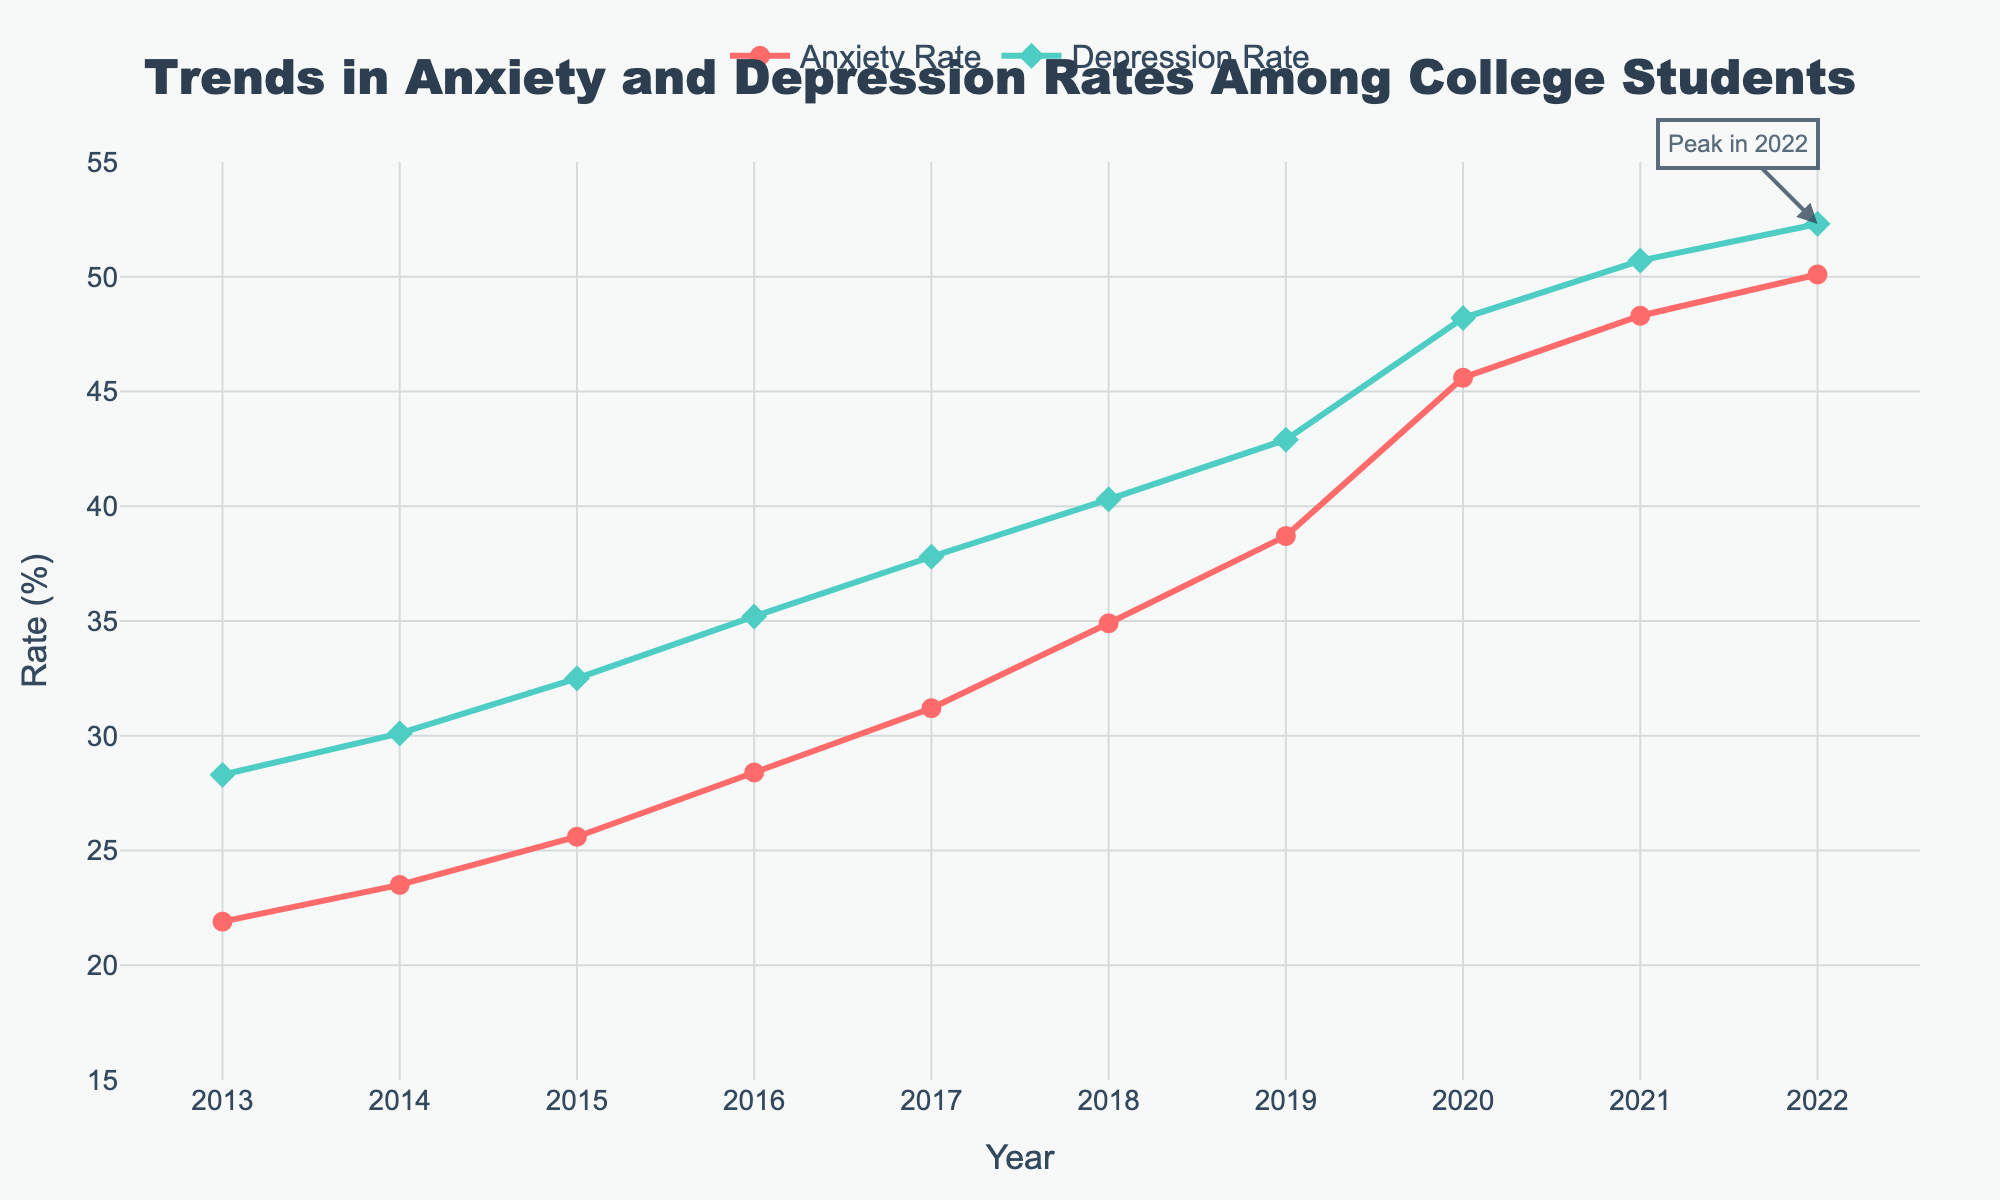What's the trend for anxiety rates from 2013 to 2022? To determine the trend, observe the line representing Anxiety Rate. It starts at 21.9% in 2013 and increases each year, reaching 50.1% in 2022. The trend shows a steady increase over the years.
Answer: Steady increase During which year did the depression rate have the highest increase compared to the previous year? Analyze the yearly increments for the Depression Rate. The largest yearly increase is between 2019 and 2020, where it rose from 42.9% to 48.2%, an increase of 5.3%.
Answer: 2020 What is the median anxiety rate over the past decade? The median is the middle value when data points are arranged in order. The anxiety rates are: 21.9, 23.5, 25.6, 28.4, 31.2, 34.9, 38.7, 45.6, 48.3, 50.1. The median value lies between the 5th and 6th values in this sorted list: (31.2 + 34.9) / 2 = 33.05%.
Answer: 33.05% By how much did the depression rate increase from 2013 to 2022? Subtract the Depression Rate in 2013 from the rate in 2022: 52.3% - 28.3% = 24.0%.
Answer: 24.0% Which year has the highest depression rate and what is it? Locate the peak of the Depression Rate line in the chart. The highest rate is in 2022, indicated by an annotation in the chart, at 52.3%.
Answer: 2022, 52.3% Compare the anxiety and depression rates in 2017. Which one was higher? Look at the rates for both in 2017: Anxiety Rate is 31.2% and Depression Rate is 37.8%. The Depression Rate is higher.
Answer: Depression Rate What is the difference between the anxiety rates in 2016 and 2020? Subtract the Anxiety Rate in 2016 from the rate in 2020: 45.6% - 28.4% = 17.2%.
Answer: 17.2% What is the average depression rate over the decade? Sum the Depression Rates from 2013 to 2022 and then divide by the number of years: (28.3 + 30.1 + 32.5 + 35.2 + 37.8 + 40.3 + 42.9 + 48.2 + 50.7 + 52.3) / 10 = 39.83%.
Answer: 39.83% How many years does it take for the anxiety rate to double from its value in 2013? The Anxiety Rate in 2013 is 21.9%. It doubles to approximately 43.8%. The year it first exceeds this is 2020, with a rate of 45.6%. So it takes 2020 - 2013 = 7 years.
Answer: 7 years 